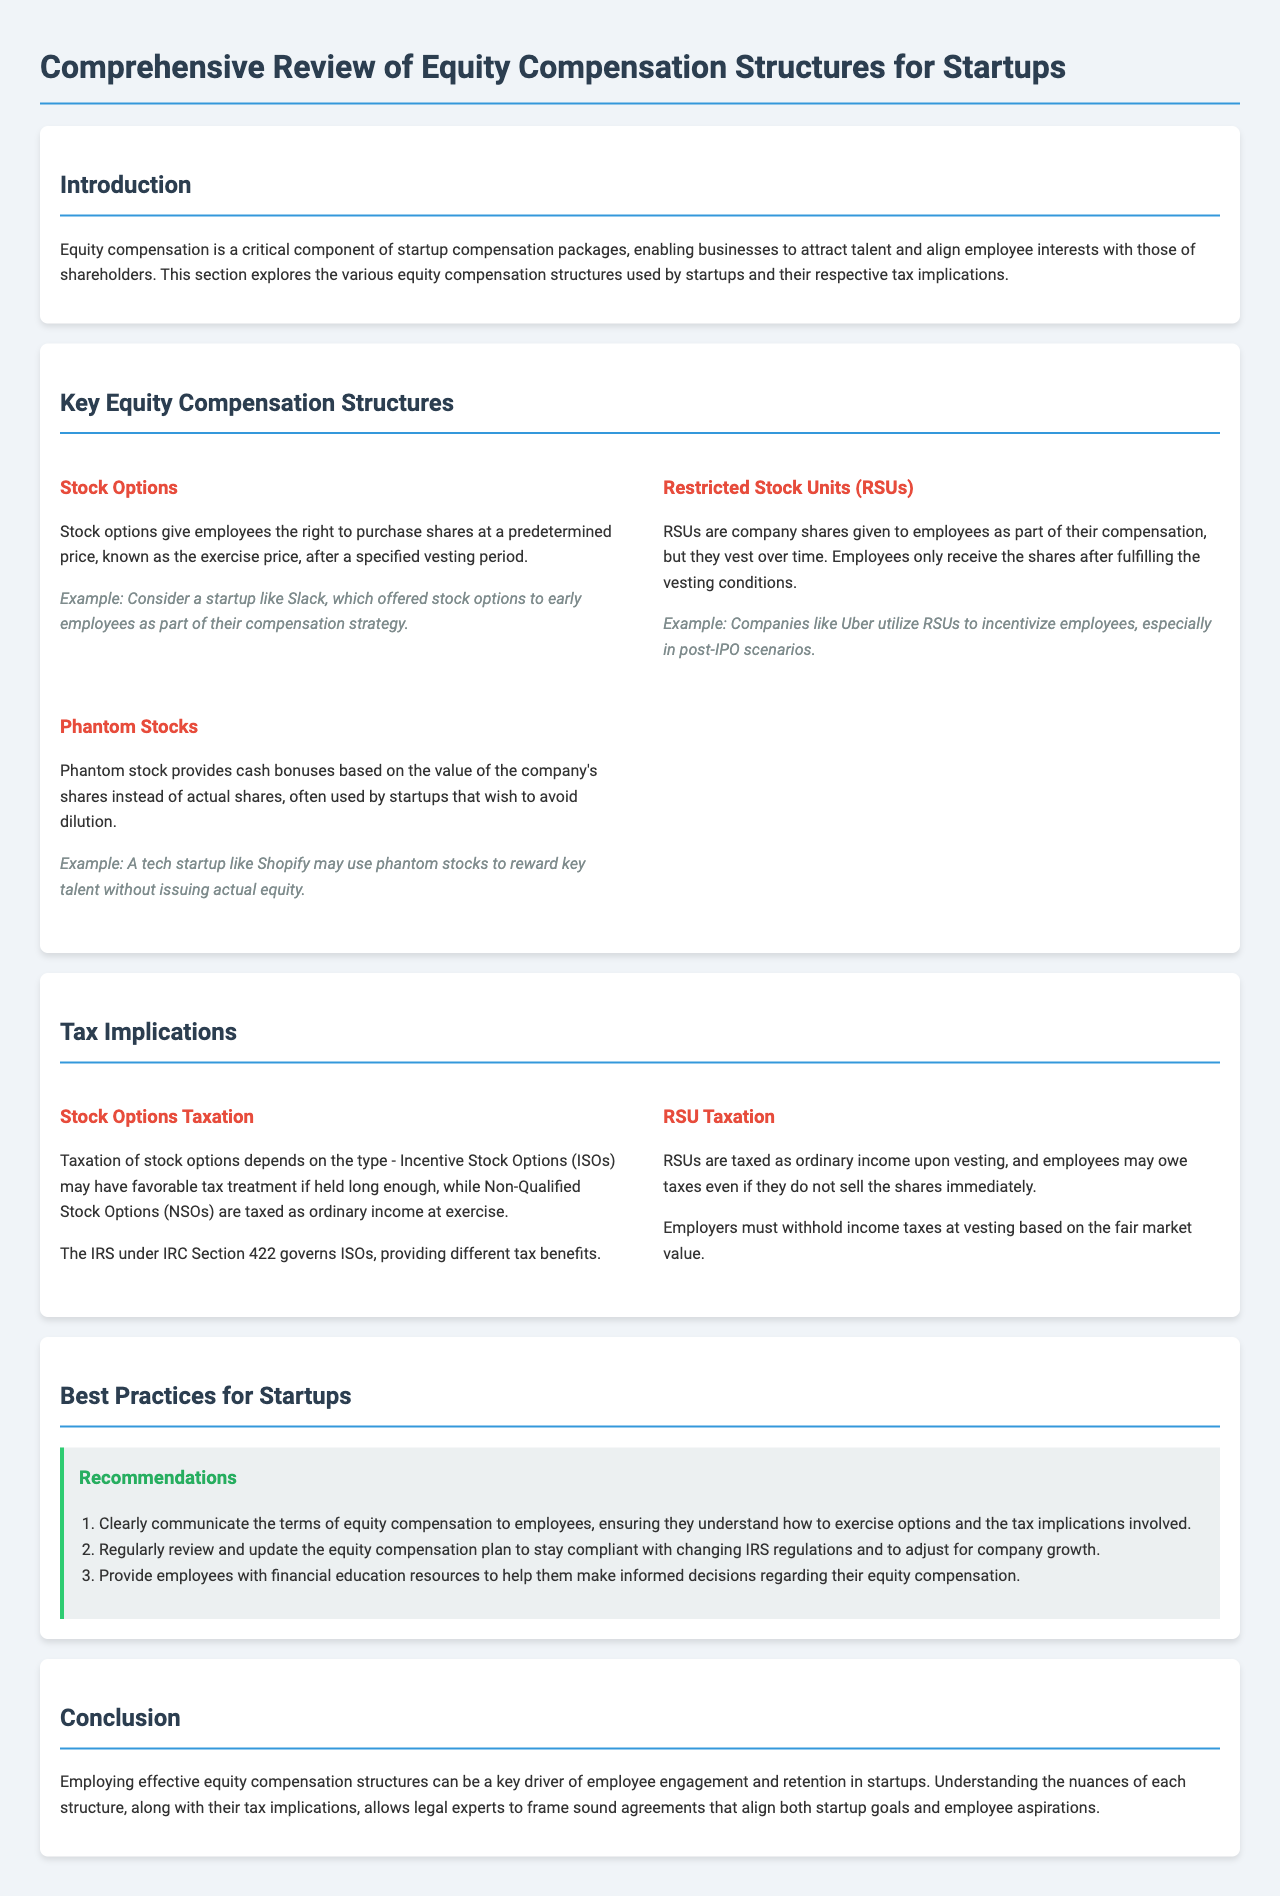What is the title of the report? The title of the report is given at the top, summarizing the core subject of the content.
Answer: Comprehensive Review of Equity Compensation Structures for Startups Including Tax Implications and Best Practices What are stock options? Stock options are defined as a specific type of equity compensation that provides employees the right to purchase shares at a predetermined price.
Answer: The right to purchase shares at a predetermined price What is RSU taxation based on? RSU taxation is specified to occur as ordinary income upon vesting, according to the document.
Answer: Ordinary income upon vesting Which type of stock options may have favorable tax treatment? The report mentions a specific category of stock options that qualifies for favorable tax treatment under certain conditions.
Answer: Incentive Stock Options (ISOs) What is a recommended best practice for startups regarding equity compensation? The report outlines best practices, including ensuring employees understand the terms of equity compensation.
Answer: Clearly communicate the terms of equity compensation Which company uses RSUs to incentivize employees? The report provides an example of a well-known company that utilizes RSUs for employee incentives.
Answer: Uber 